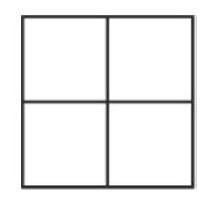Given that one row sums to 4 and another to 5, which number must be in the bottom-right cell? With the bottom row summing to 4 and the right column summing to 5, the bottom-right cell must contain the number 2, as it's the only configuration where the values fit the given sums when we place the numbers 1 and 3 in the top row and the numbers 2 and 4 in the bottom row. 